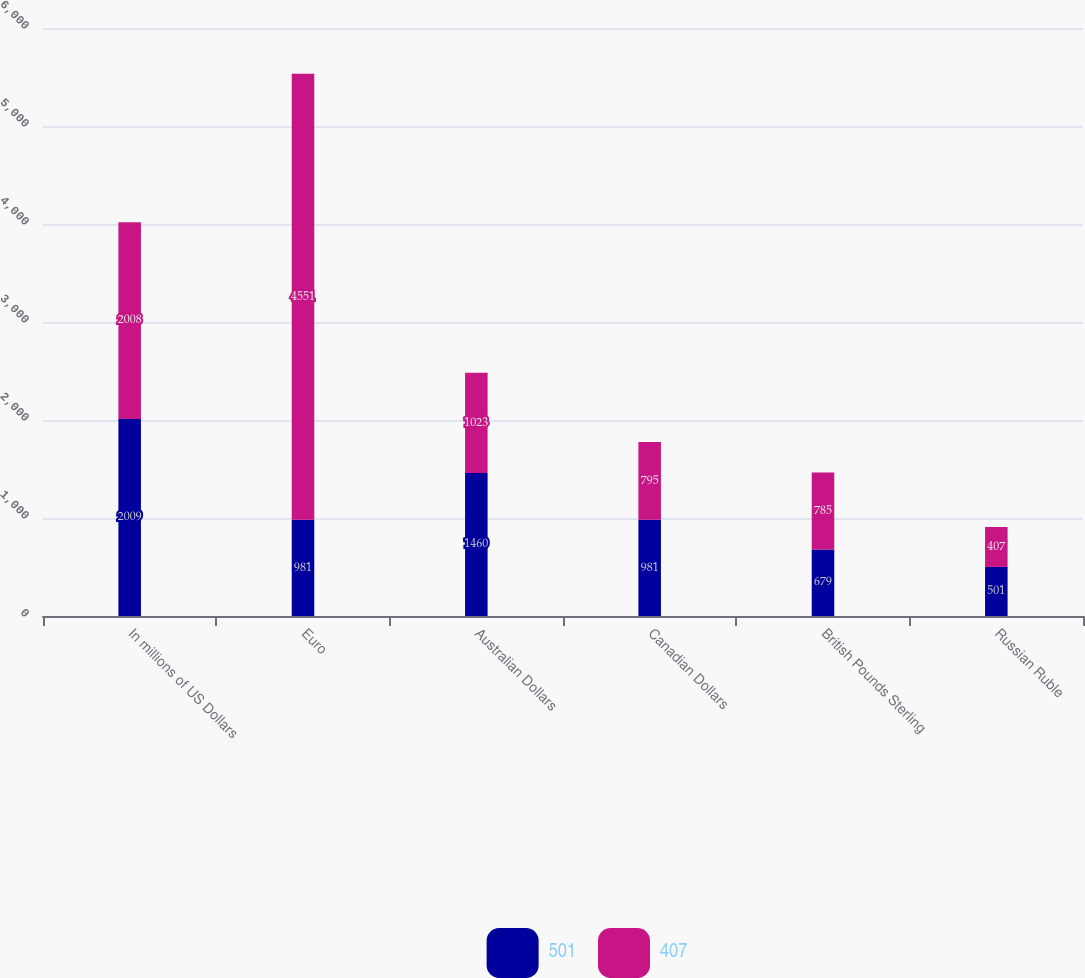Convert chart. <chart><loc_0><loc_0><loc_500><loc_500><stacked_bar_chart><ecel><fcel>In millions of US Dollars<fcel>Euro<fcel>Australian Dollars<fcel>Canadian Dollars<fcel>British Pounds Sterling<fcel>Russian Ruble<nl><fcel>501<fcel>2009<fcel>981<fcel>1460<fcel>981<fcel>679<fcel>501<nl><fcel>407<fcel>2008<fcel>4551<fcel>1023<fcel>795<fcel>785<fcel>407<nl></chart> 